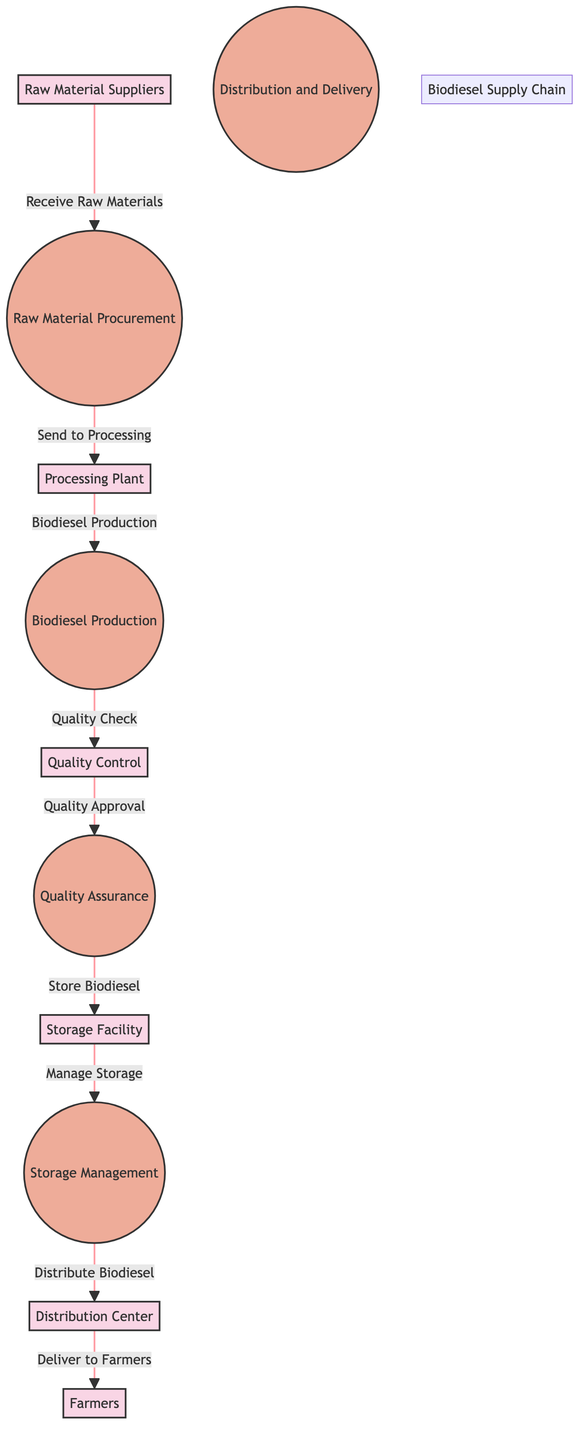What are the end-users of biodiesel in this diagram? The diagram indicates that the end-users of biodiesel are referred to as "Farmers." They utilize biodiesel for their agricultural equipment.
Answer: Farmers How many main processes are there in the biodiesel supply chain? The diagram displays five main processes related to biodiesel production, which are Raw Material Procurement, Biodiesel Production, Quality Assurance, Storage Management, and Distribution and Delivery.
Answer: Five What is the primary function of the Quality Control department? The Quality Control department is tasked with ensuring that the biodiesel meets required standards after production, which is critical for maintaining product quality.
Answer: Ensuring quality Which entity receives raw materials after procurement? The diagram shows that the "Processing Plant" is the next entity that receives raw materials after they have been procured from suppliers.
Answer: Processing Plant What is the output of the Quality Assurance process? After Quality Assurance, the output is directed towards the "Storage Facility," meaning that the biodiesel has passed quality checks and is now ready to be stored.
Answer: Storage Facility Which process is responsible for managing the logistics of biodiesel to farmers? The process responsible for managing the logistics and delivery of biodiesel to farmers is the "Distribution and Delivery" process, which is crucial for ensuring timely delivery to end-users.
Answer: Distribution and Delivery What comes after the Biodiesel Production process? Once Biodiesel Production is completed, the next step is the "Quality Control" process, where the quality of the produced biodiesel is checked to ensure it meets standards.
Answer: Quality Control From which facility do farmers receive biodiesel? According to the diagram, farmers receive biodiesel from the "Distribution Center," which serves as the hub for delivery and logistics.
Answer: Distribution Center 